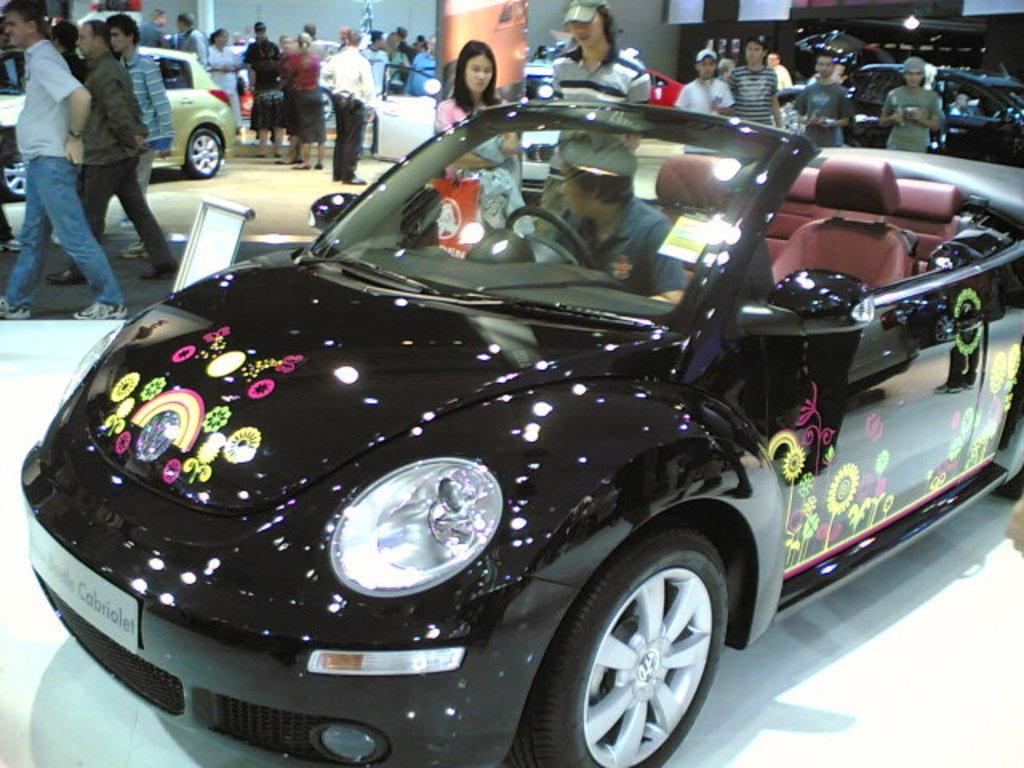How would you summarize this image in a sentence or two? This picture shows a man seated in the car and we see few people standing around 